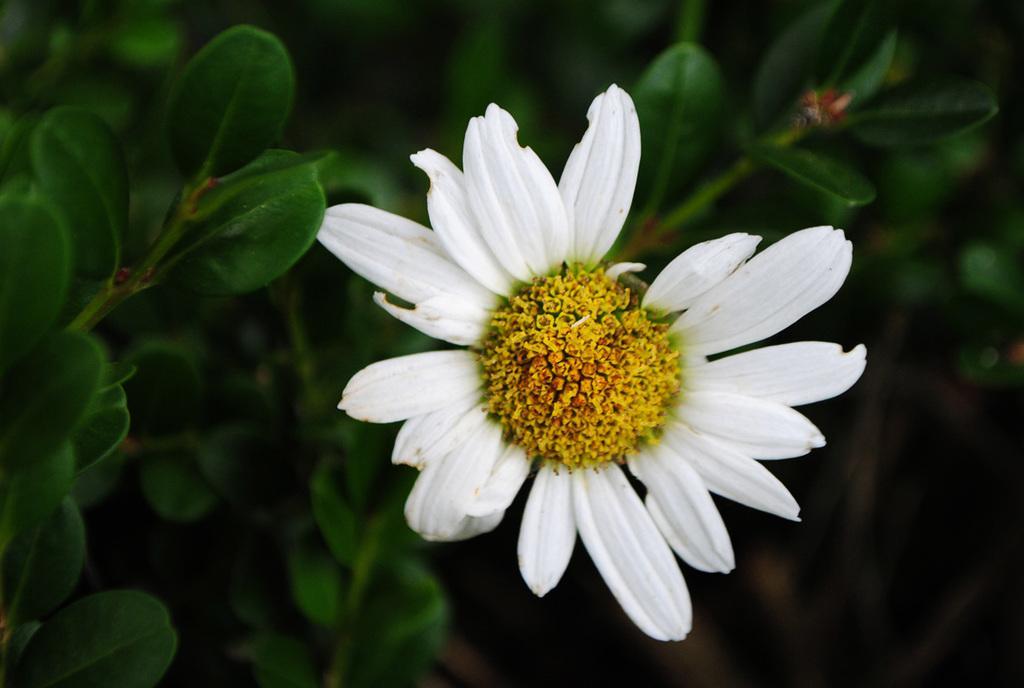Please provide a concise description of this image. In this image we can see a flower. In the background there are leaves and it is blurry. 